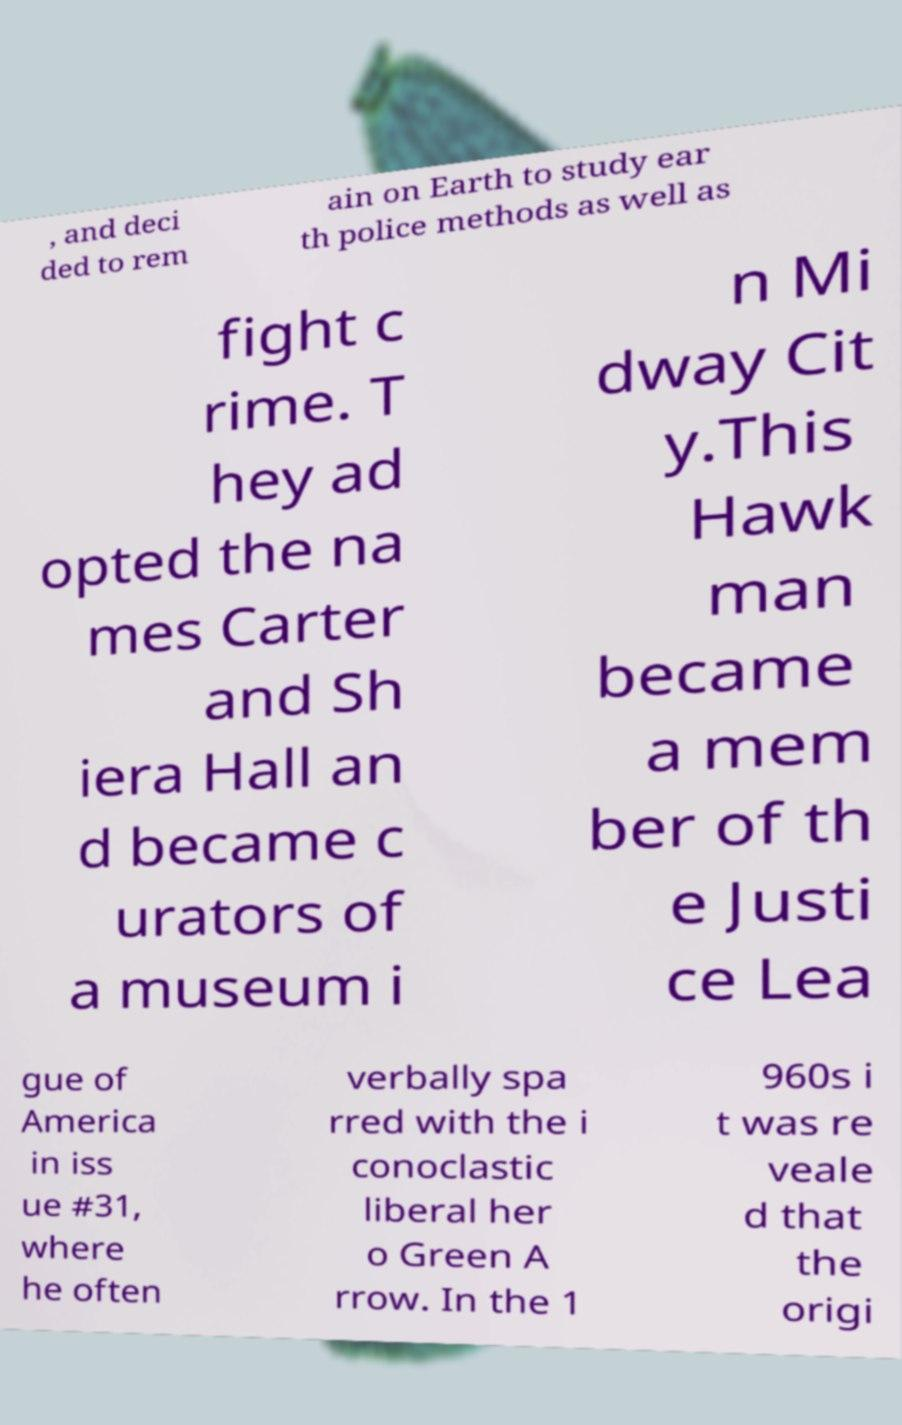Could you assist in decoding the text presented in this image and type it out clearly? , and deci ded to rem ain on Earth to study ear th police methods as well as fight c rime. T hey ad opted the na mes Carter and Sh iera Hall an d became c urators of a museum i n Mi dway Cit y.This Hawk man became a mem ber of th e Justi ce Lea gue of America in iss ue #31, where he often verbally spa rred with the i conoclastic liberal her o Green A rrow. In the 1 960s i t was re veale d that the origi 